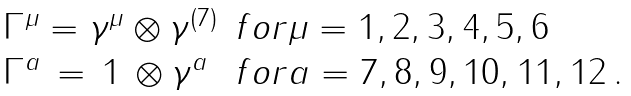Convert formula to latex. <formula><loc_0><loc_0><loc_500><loc_500>\begin{array} { l l } \Gamma ^ { \mu } = \gamma ^ { \mu } \otimes \gamma ^ { ( 7 ) } & f o r \mu = 1 , 2 , 3 , 4 , 5 , 6 \\ \Gamma ^ { a } \, = \, 1 \, \otimes \gamma ^ { a } & f o r a = 7 , 8 , 9 , 1 0 , 1 1 , 1 2 \, . \end{array}</formula> 